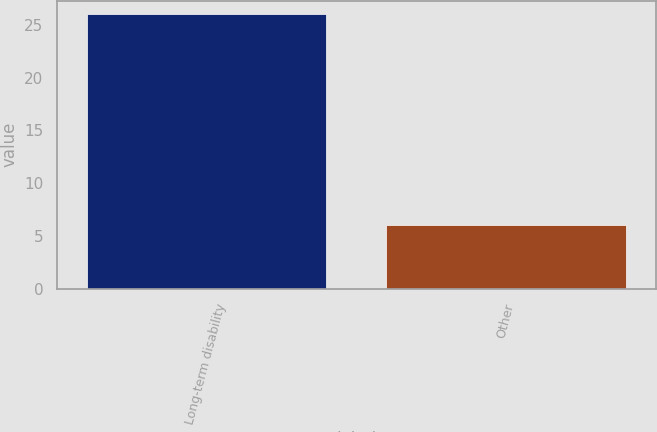Convert chart. <chart><loc_0><loc_0><loc_500><loc_500><bar_chart><fcel>Long-term disability<fcel>Other<nl><fcel>26<fcel>6<nl></chart> 